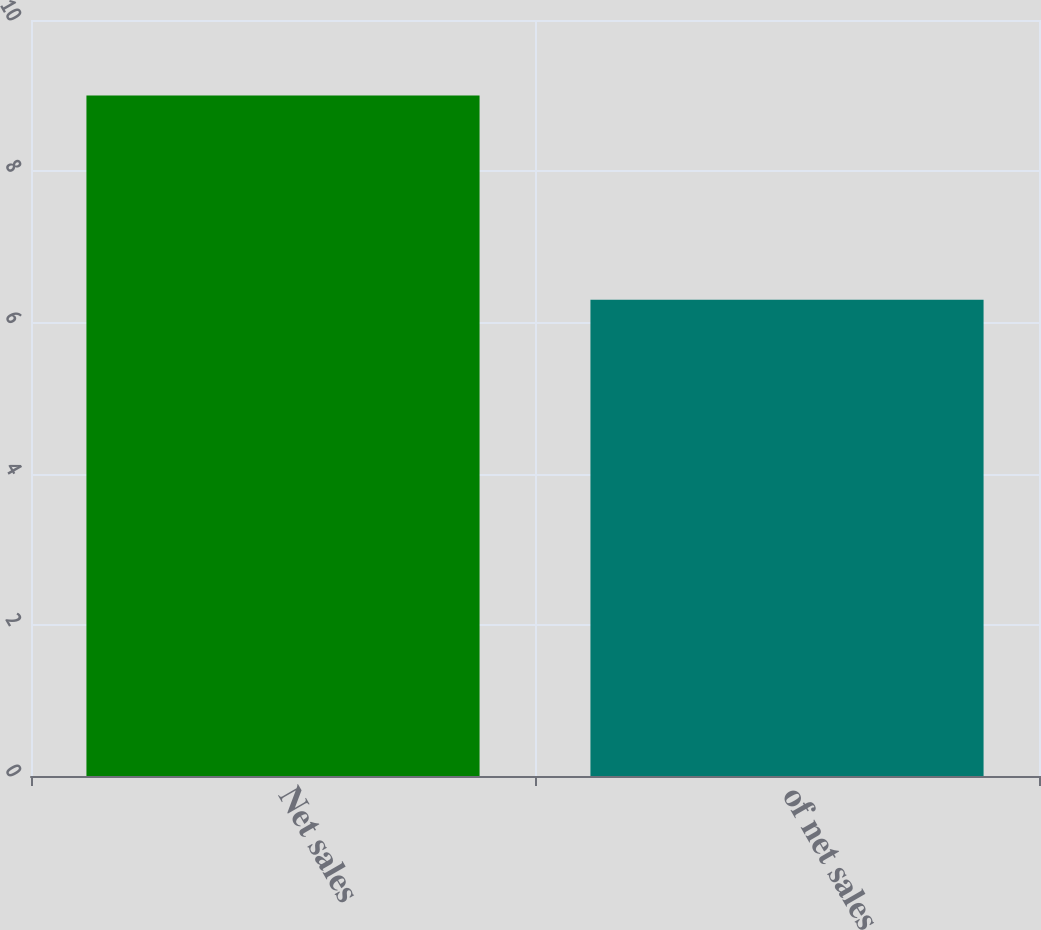Convert chart to OTSL. <chart><loc_0><loc_0><loc_500><loc_500><bar_chart><fcel>Net sales<fcel>of net sales<nl><fcel>9<fcel>6.3<nl></chart> 